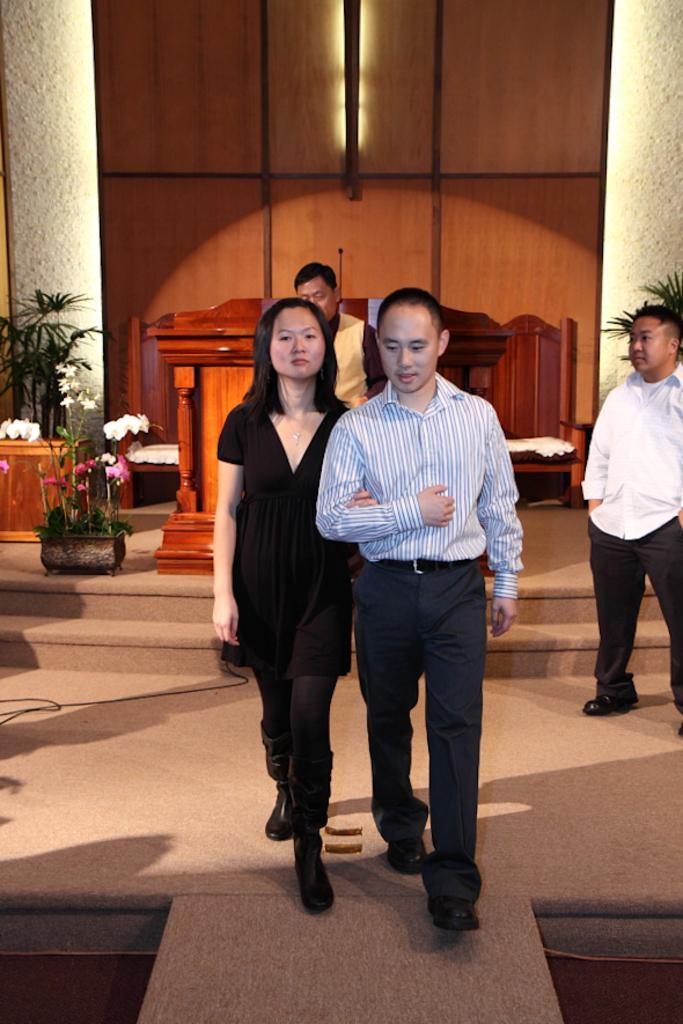Please provide a concise description of this image. The man in blue shirt and the woman in the black dress is walking on the ramp. Behind them, we see the man in the yellow jacket is standing. On the right side, the man in the white shirt is standing. Behind them, we see a podium on which microphone is placed. Beside that, there are flower pots. On either side of the picture, we see pillars. In the background, we see a wall in brown color. 